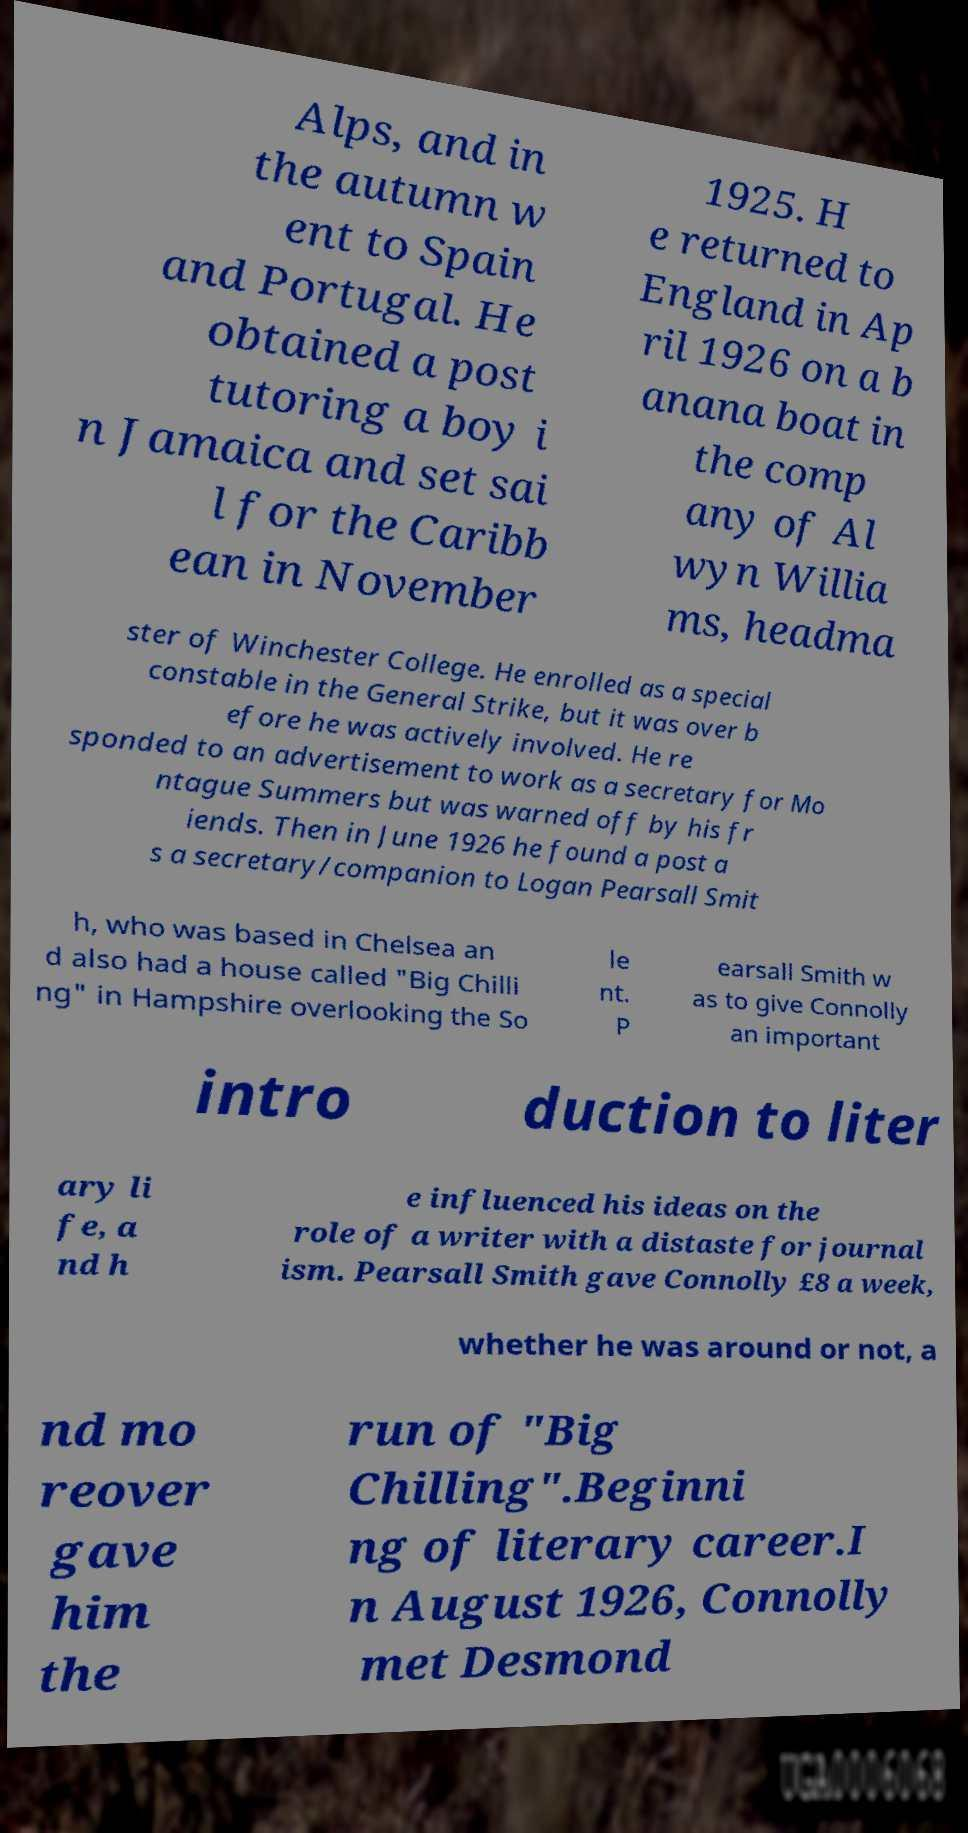Please identify and transcribe the text found in this image. Alps, and in the autumn w ent to Spain and Portugal. He obtained a post tutoring a boy i n Jamaica and set sai l for the Caribb ean in November 1925. H e returned to England in Ap ril 1926 on a b anana boat in the comp any of Al wyn Willia ms, headma ster of Winchester College. He enrolled as a special constable in the General Strike, but it was over b efore he was actively involved. He re sponded to an advertisement to work as a secretary for Mo ntague Summers but was warned off by his fr iends. Then in June 1926 he found a post a s a secretary/companion to Logan Pearsall Smit h, who was based in Chelsea an d also had a house called "Big Chilli ng" in Hampshire overlooking the So le nt. P earsall Smith w as to give Connolly an important intro duction to liter ary li fe, a nd h e influenced his ideas on the role of a writer with a distaste for journal ism. Pearsall Smith gave Connolly £8 a week, whether he was around or not, a nd mo reover gave him the run of "Big Chilling".Beginni ng of literary career.I n August 1926, Connolly met Desmond 